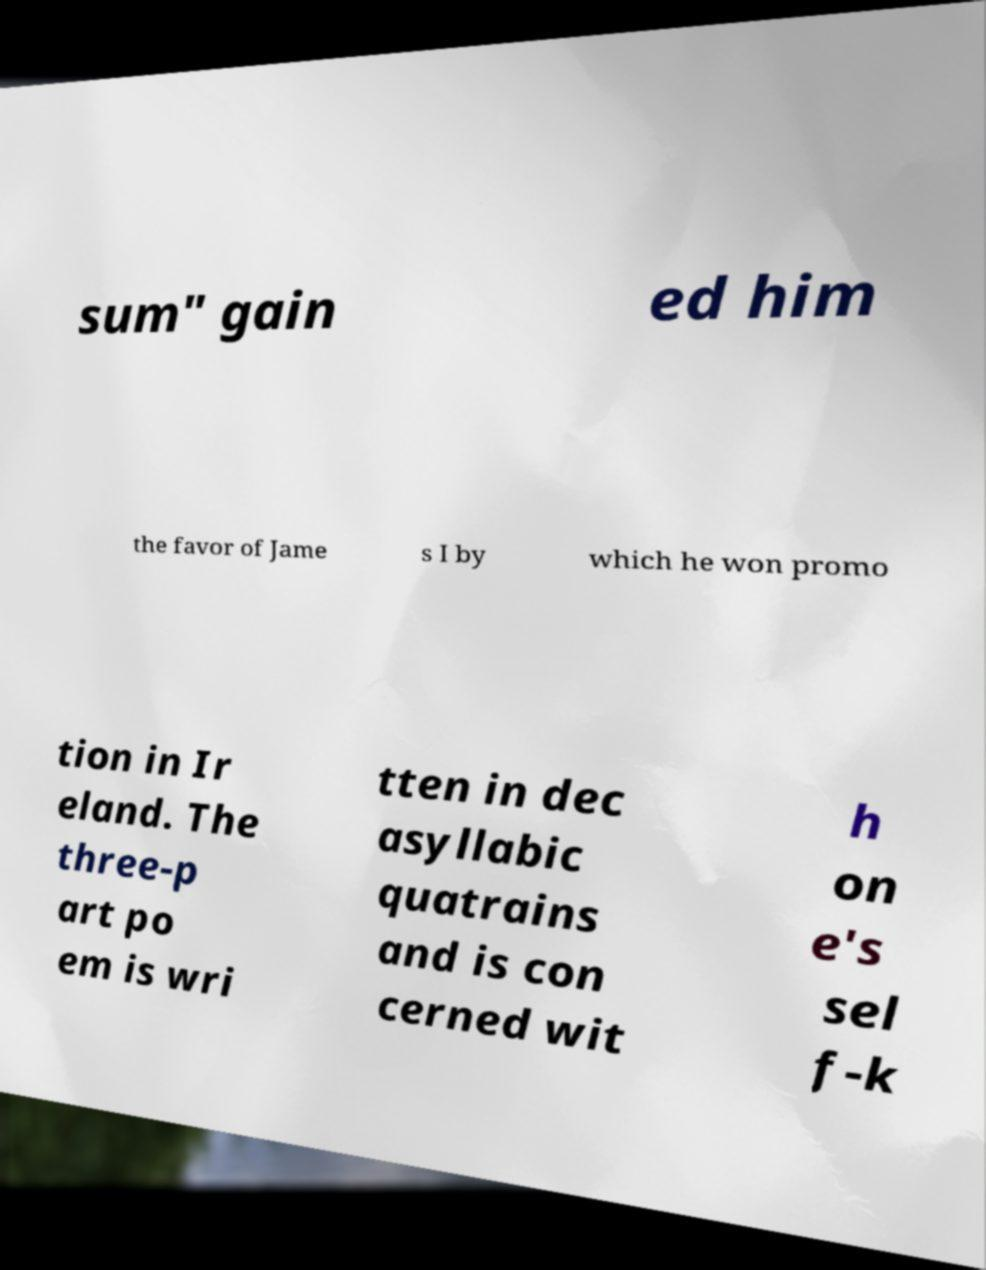Please read and relay the text visible in this image. What does it say? sum" gain ed him the favor of Jame s I by which he won promo tion in Ir eland. The three-p art po em is wri tten in dec asyllabic quatrains and is con cerned wit h on e's sel f-k 